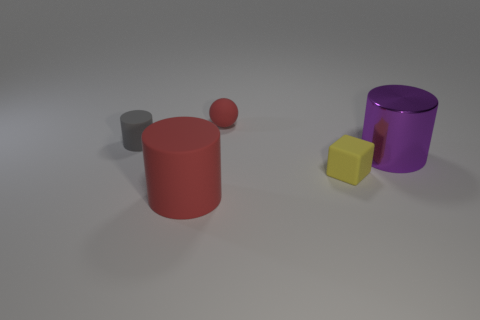Can you tell which object is the largest and which is the smallest? Yes, based on the image, the purple cylinder seems to be the largest object while the small gray sphere appears to be the smallest. 